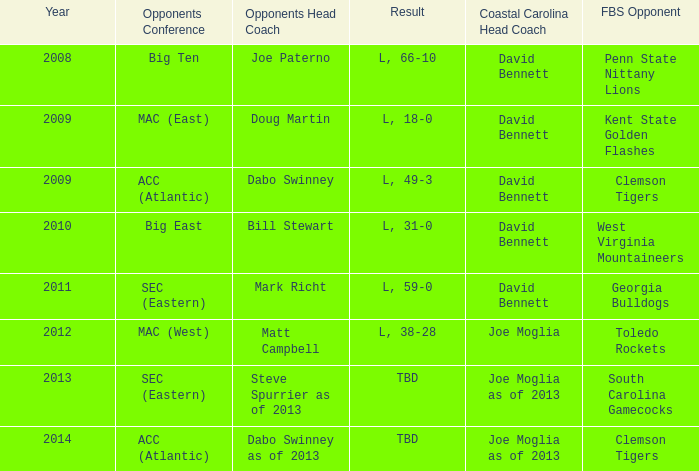What was the result when then opponents conference was Mac (east)? L, 18-0. 